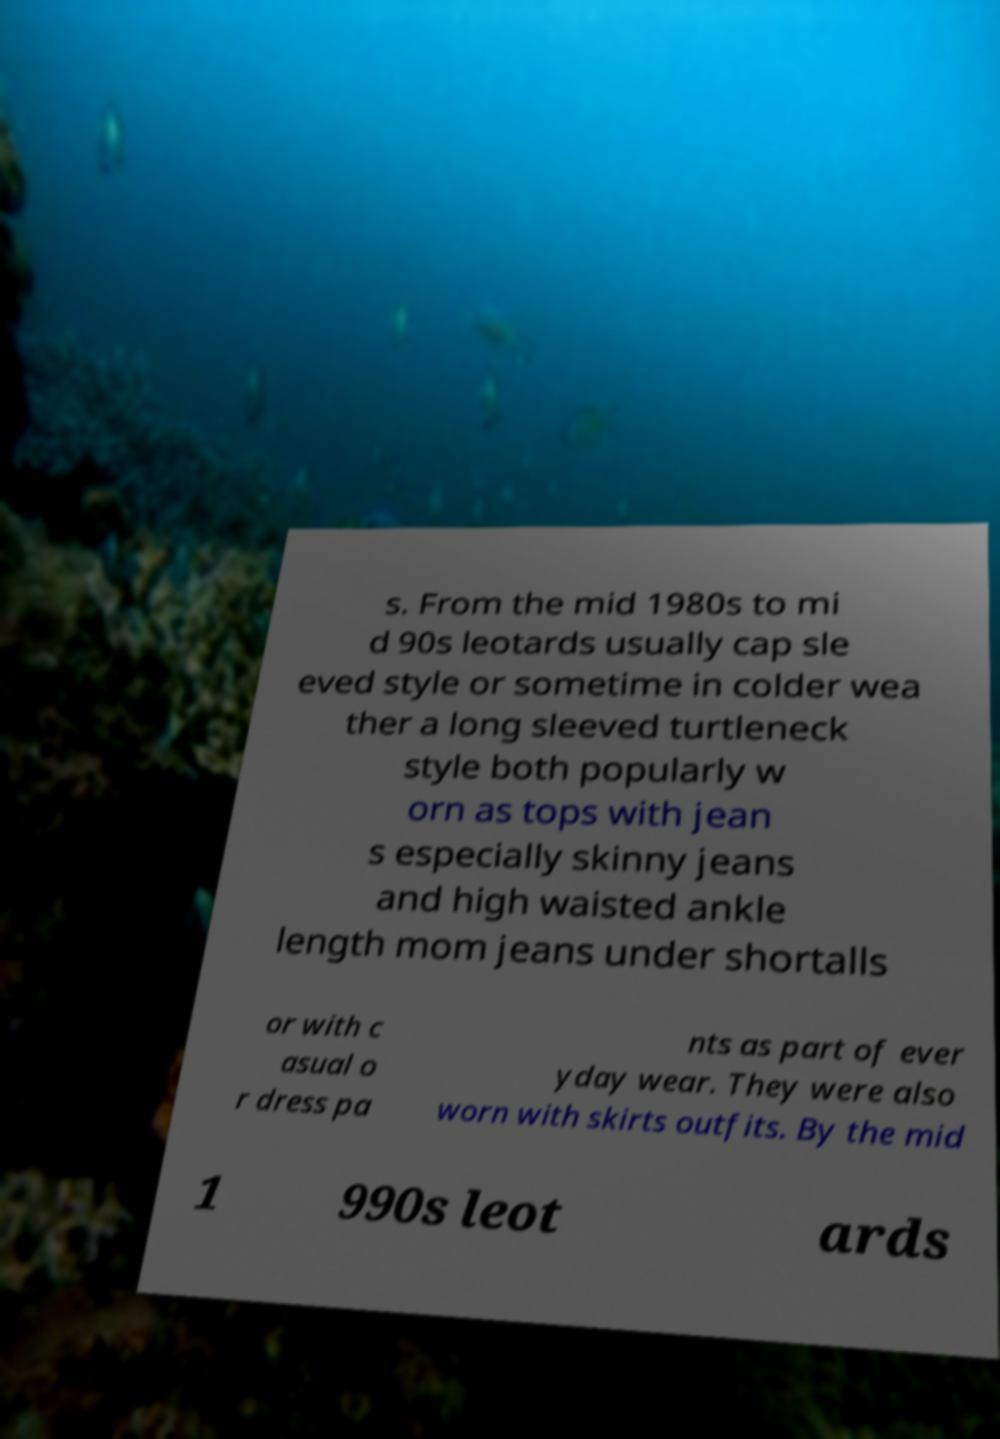Can you read and provide the text displayed in the image?This photo seems to have some interesting text. Can you extract and type it out for me? s. From the mid 1980s to mi d 90s leotards usually cap sle eved style or sometime in colder wea ther a long sleeved turtleneck style both popularly w orn as tops with jean s especially skinny jeans and high waisted ankle length mom jeans under shortalls or with c asual o r dress pa nts as part of ever yday wear. They were also worn with skirts outfits. By the mid 1 990s leot ards 